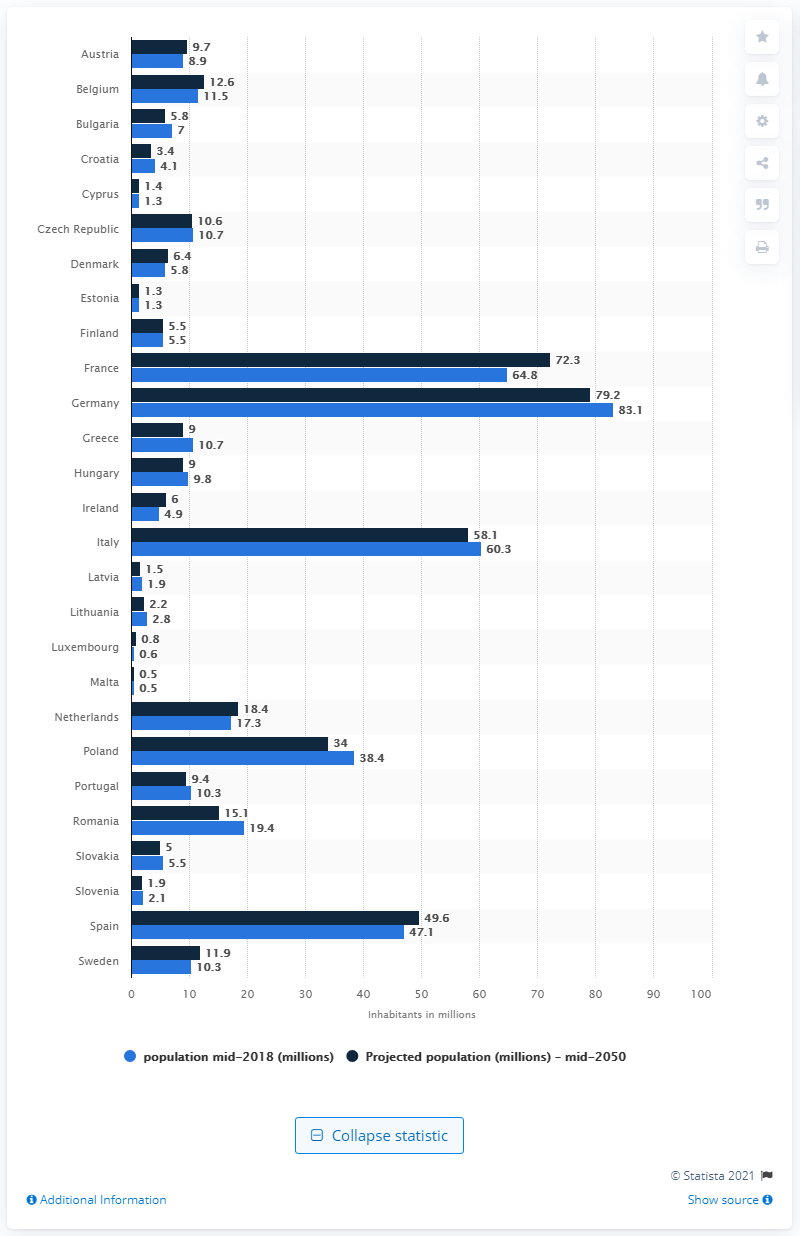Which country in this chart is projected to have the largest population increase by 2050? The chart projects that France will have the largest population increase by 2050, growing from 64.8 million to 72.3 million inhabitants. 